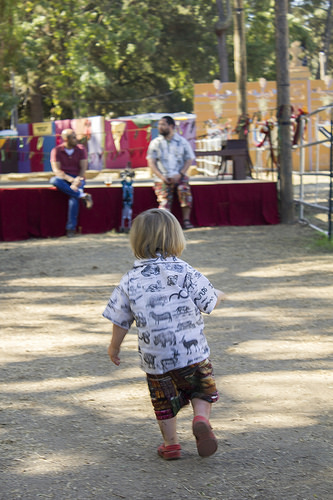<image>
Can you confirm if the rhino is on the shirt? Yes. Looking at the image, I can see the rhino is positioned on top of the shirt, with the shirt providing support. Is there a man to the left of the boy? Yes. From this viewpoint, the man is positioned to the left side relative to the boy. 